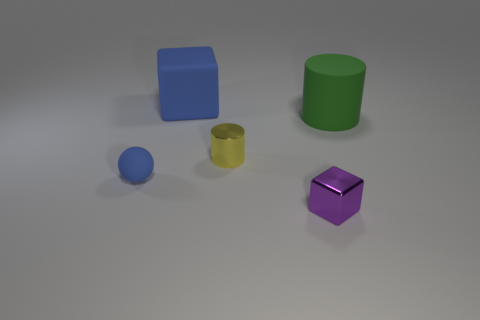Can you describe the colors and shapes of the objects present? Certainly, the image features objects with distinct colors and shapes. From left to right: a blue cube, a green cylinder, a blue sphere, a yellow smaller cylinder, and a purple cube with some beveled edges. 